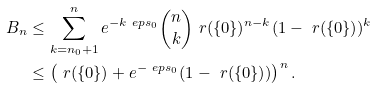Convert formula to latex. <formula><loc_0><loc_0><loc_500><loc_500>B _ { n } & \leq \sum _ { k = n _ { 0 } + 1 } ^ { n } e ^ { - k \ e p s _ { 0 } } \binom { n } { k } \ r ( \{ 0 \} ) ^ { n - k } ( 1 - \ r ( \{ 0 \} ) ) ^ { k } \\ & \leq \left ( \ r ( \{ 0 \} ) + e ^ { - \ e p s _ { 0 } } ( 1 - \ r ( \{ 0 \} ) ) \right ) ^ { n } .</formula> 